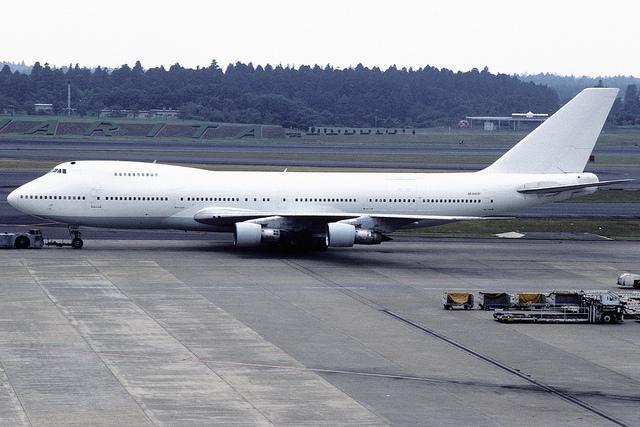How many engines on the plane?
Give a very brief answer. 4. How many large bags is the old man holding?
Give a very brief answer. 0. 